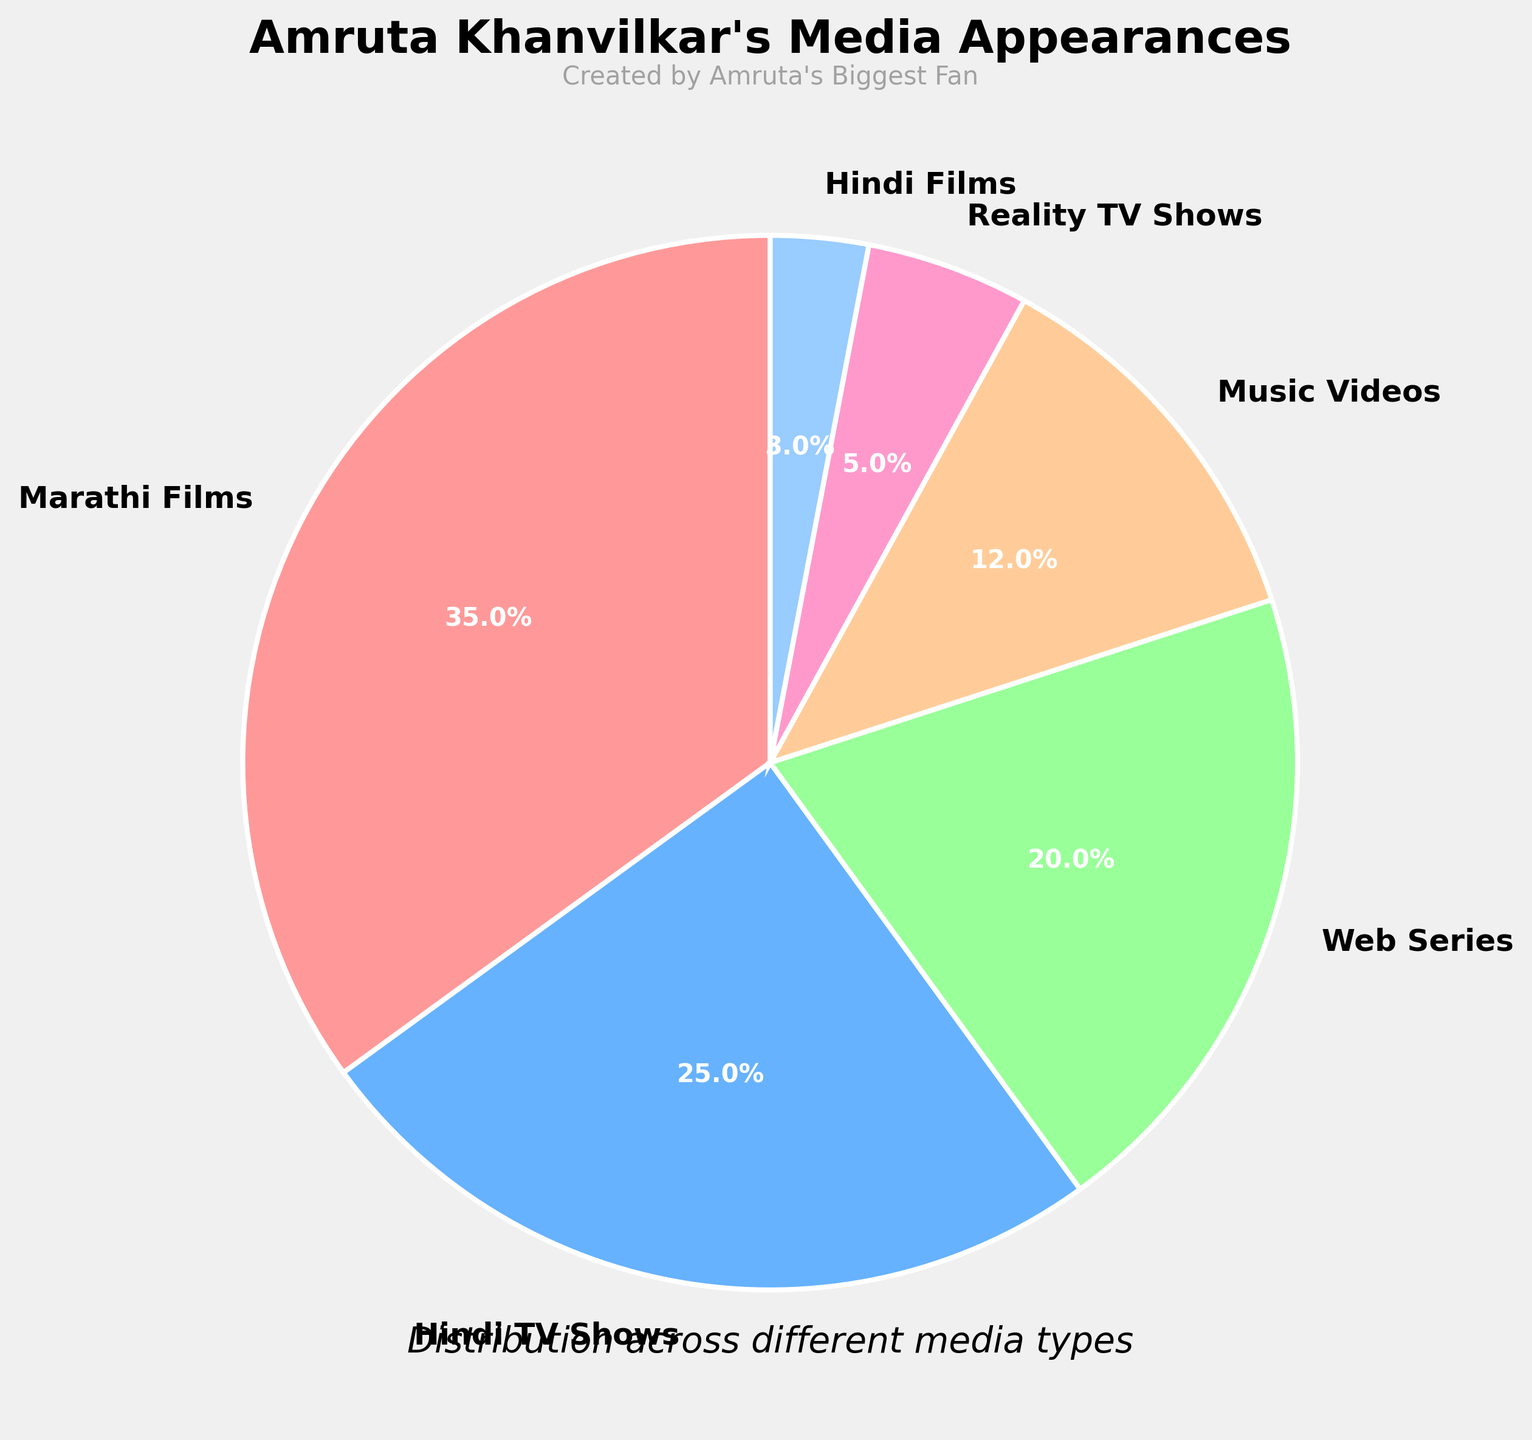Which media type does Amruta Khanvilkar appear in the most? By looking at the pie chart, we can identify that the "Marathi Films" segment is the largest, indicating the highest proportion.
Answer: Marathi Films What percentage of Amruta's appearances are in Hindi TV Shows? The pie chart shows that the Hindi TV Shows segment is labeled with 25%.
Answer: 25% How many times larger is the percentage of Marathi Films compared to Web Series? Marathi Films are labeled with 35% and Web Series with 20%. Calculate the ratio: 35 / 20 = 1.75. Thus, the Marathi Films segment is 1.75 times larger than the Web Series segment.
Answer: 1.75 times Which media type has the smallest percentage of appearances? The smallest slice in the pie chart represents Hindi Films, which is labeled with 3%.
Answer: Hindi Films What is the combined percentage of Music Videos and Reality TV Shows? The Music Videos segment is labeled with 12% and Reality TV Shows with 5%. Combine these by adding their percentages: 12 + 5 = 17.
Answer: 17% What is the difference in percentage between Marathi Films and Hindi TV Shows? Marathi Films are labeled with 35% and Hindi TV Shows with 25%. Subtract the smaller percentage from the larger one: 35 - 25 = 10.
Answer: 10% Which segment is colored blue, and what does it represent? Referring to the provided color scheme and pie chart, the segment colored blue represents Hindi TV Shows.
Answer: Hindi TV Shows Are Music Videos or Web Series a larger portion of Amruta's appearances? By observing the pie chart, the Music Videos segment is labeled with 12% and the Web Series with 20%. Web Series is a larger portion.
Answer: Web Series What is the combined percentage of Amruta's appearances in films (Marathi and Hindi)? Marathi Films are labeled with 35% and Hindi Films with 3%. Combine these by adding their percentages: 35 + 3 = 38.
Answer: 38% How many different types of media appearances are listed? The pie chart includes segments for Marathi Films, Hindi TV Shows, Web Series, Music Videos, Reality TV Shows, and Hindi Films. Count these segments: 6.
Answer: 6 